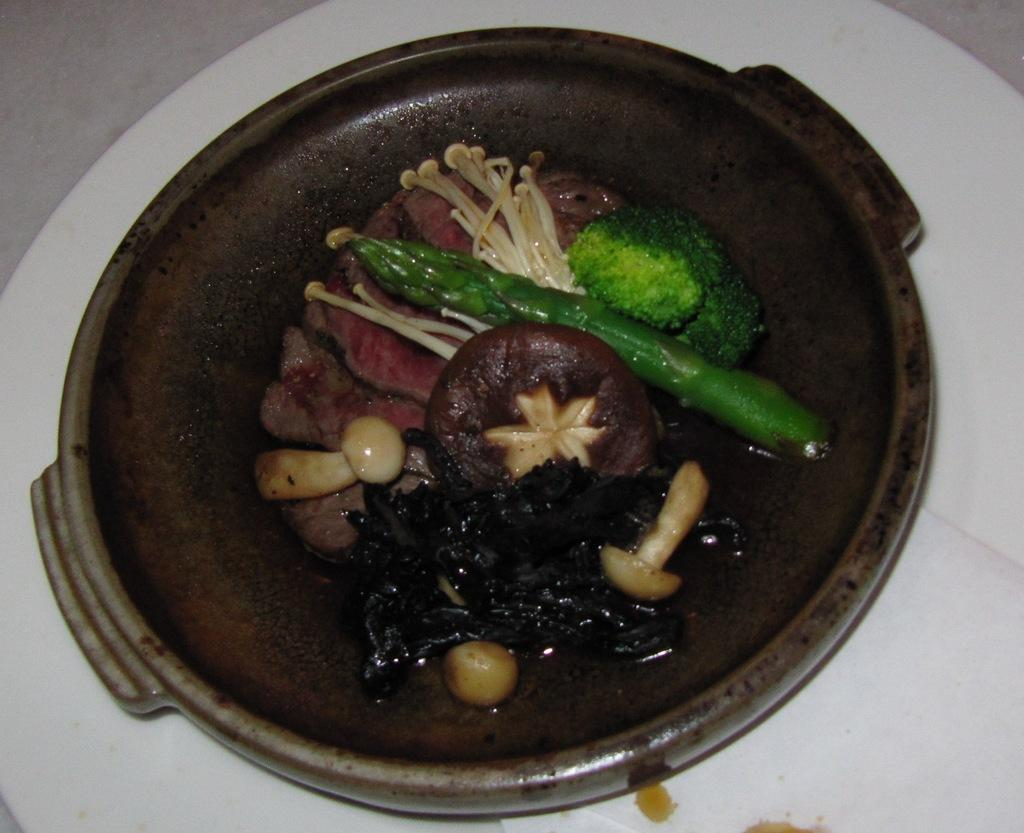What type of food is visible in the image? There are cooked mushrooms and vegetables in the image. How are the food items arranged in the image? The food items are served in a bowl. How many armies are present in the image? There are no armies present in the image; it features cooked mushrooms and vegetables served in a bowl. 